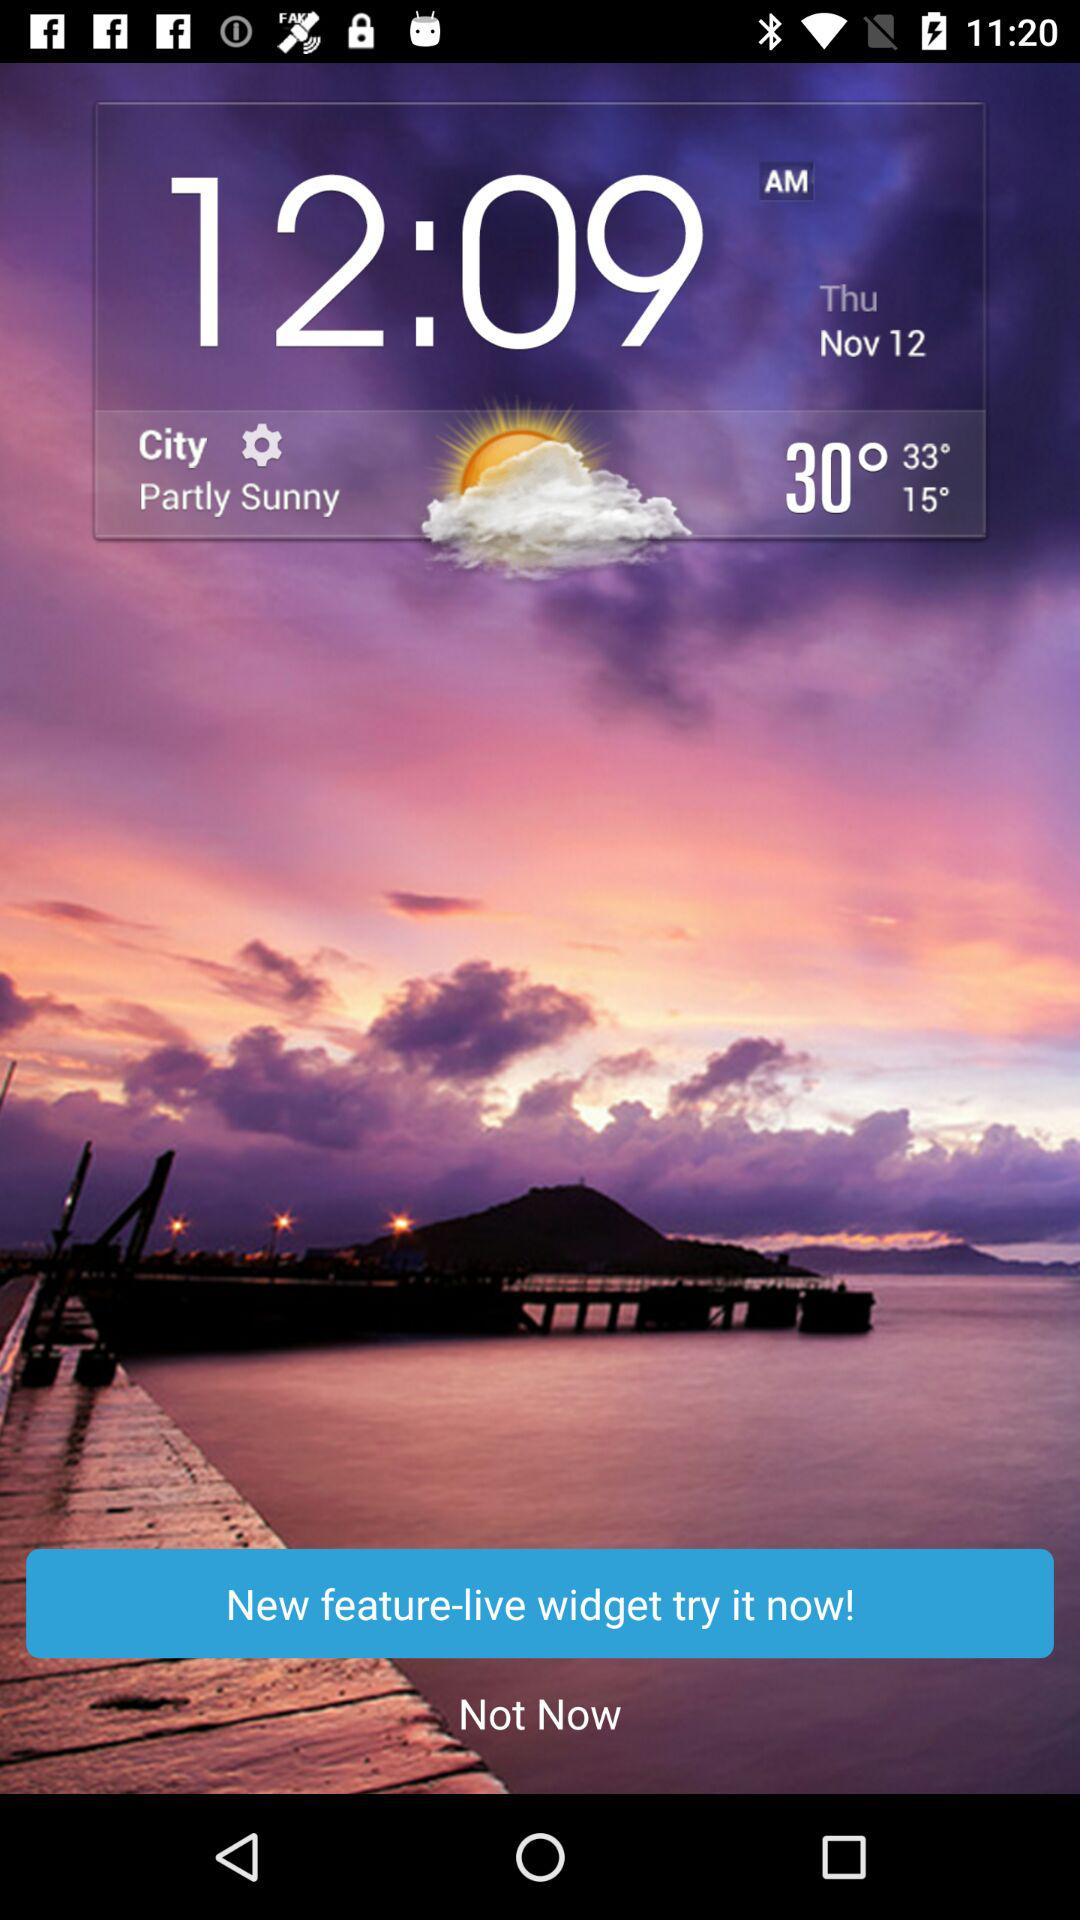How many degrees Fahrenheit is the difference between the high and low temperatures?
Answer the question using a single word or phrase. 18 